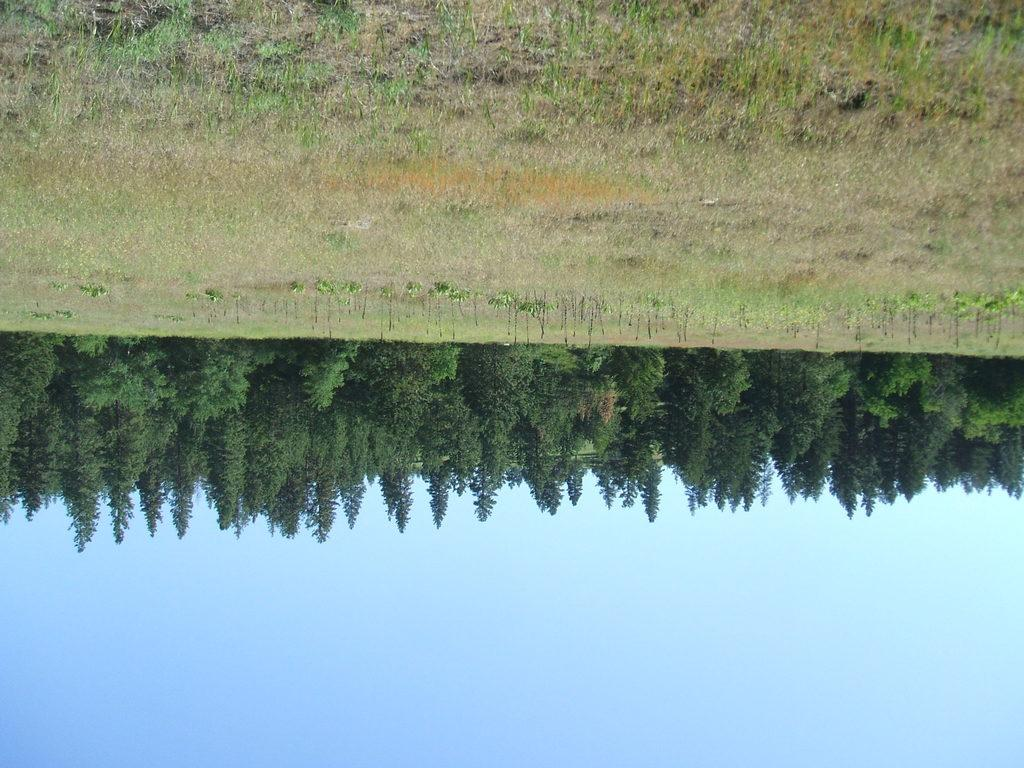What type of vegetation can be seen in the image? There are trees and plants in the image. What covers the ground in the image? There is grass on the ground in the image. What color is the sky in the image? The sky is blue in the image. How many items are on the list in the image? There is no list present in the image. What type of worm can be seen crawling on the grass in the image? There are no worms visible in the image; it only features trees, plants, grass, and a blue sky. 